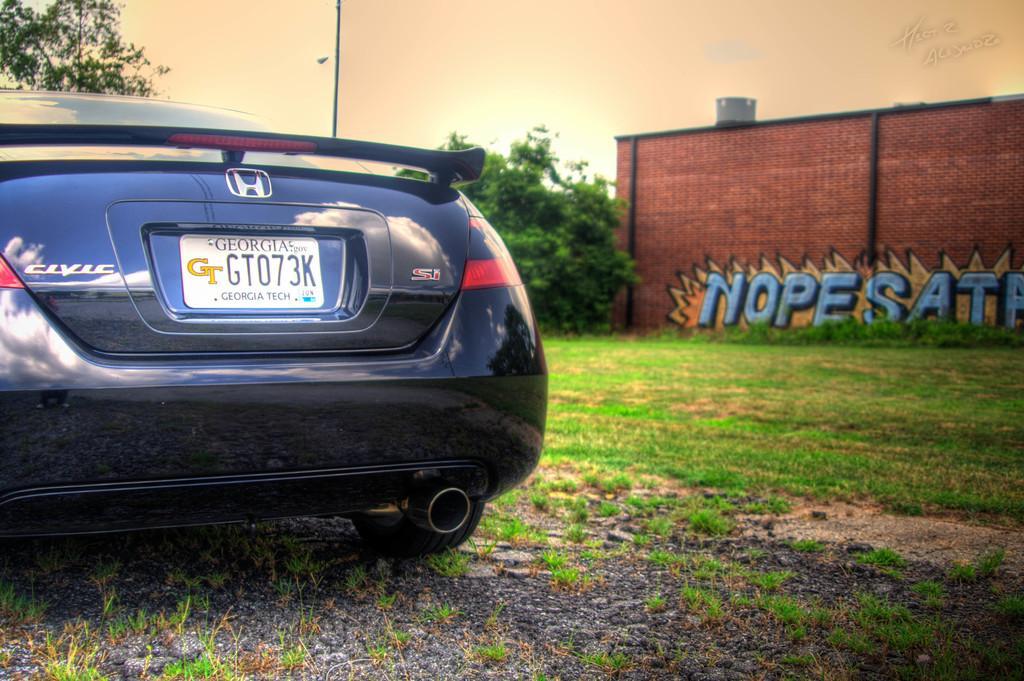Describe this image in one or two sentences. On the left side of the image we can see a car. On the right side of the image we can see graffiti on the wall. In the background of the image we can see the trees, pipes, tank. At the bottom of the image we can see the ground and grass. At the top of the image we can see the sky. In the top right corner we can see the text. 